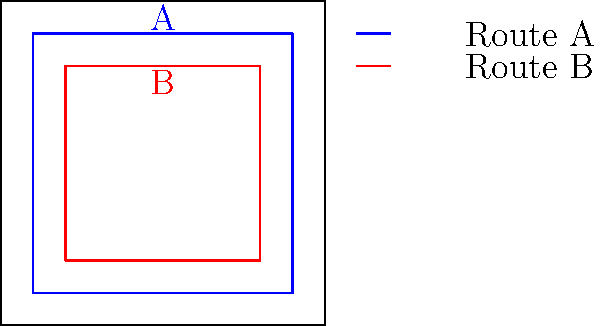The diagram shows two waste collection route layouts (A and B) for a square city grid. Route A covers a larger area but requires more travel distance, while Route B covers a smaller area but with less travel distance. If the goal is to maximize the area covered while minimizing fuel consumption, which route would you recommend, and why? To determine the most efficient route, we need to consider both the area covered and the travel distance:

1. Area covered:
   - Route A: $80 \times 80 = 6400$ square units
   - Route B: $60 \times 60 = 3600$ square units

2. Travel distance (perimeter):
   - Route A: $4 \times 80 = 320$ units
   - Route B: $4 \times 60 = 240$ units

3. Efficiency ratio (area covered / travel distance):
   - Route A: $6400 / 320 = 20$ square units per unit of travel
   - Route B: $3600 / 240 = 15$ square units per unit of travel

4. Fuel consumption:
   Assuming fuel consumption is directly proportional to travel distance, Route A will consume more fuel than Route B.

5. Cost-effectiveness:
   Route A covers 33% more area per unit of travel, which could lead to fewer trips and potentially lower overall fuel consumption in the long run.

6. Policy implications:
   As a waste management regulator focusing on cost-effective policies, Route A offers a better balance between coverage and efficiency, potentially reducing the number of trips required and overall operational costs.
Answer: Route A, as it offers higher efficiency (20 vs. 15 square units per unit of travel) and better long-term cost-effectiveness despite higher initial fuel consumption. 